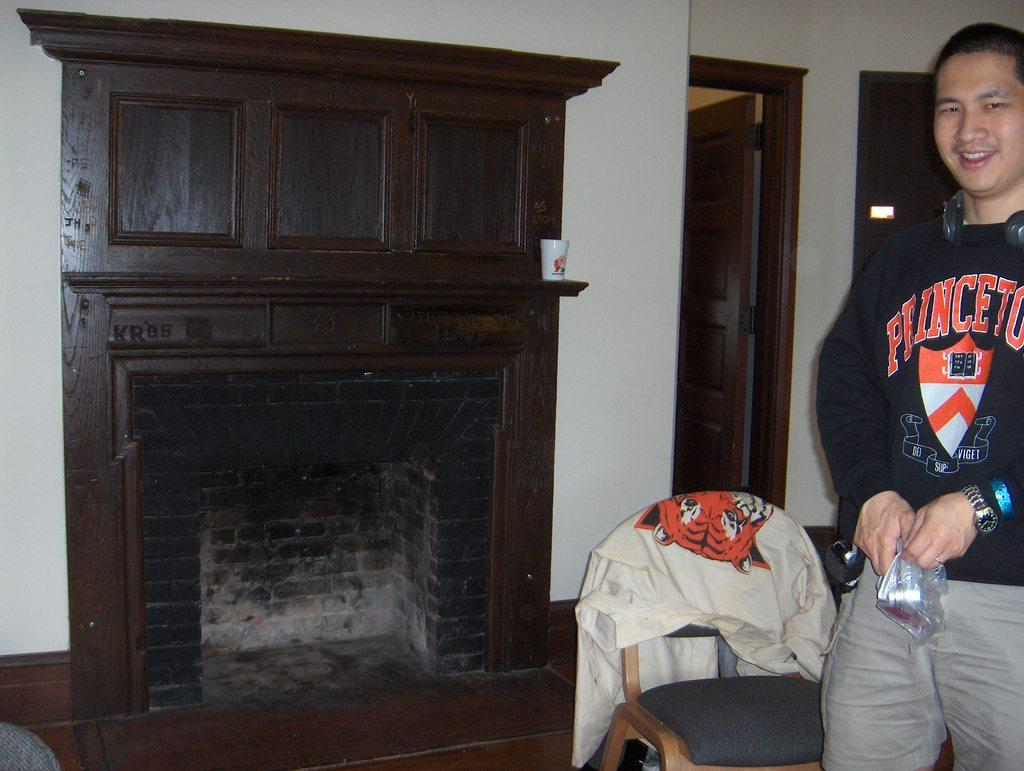<image>
Offer a succinct explanation of the picture presented. An Asian man in a Princeton sweater holds a bag. 